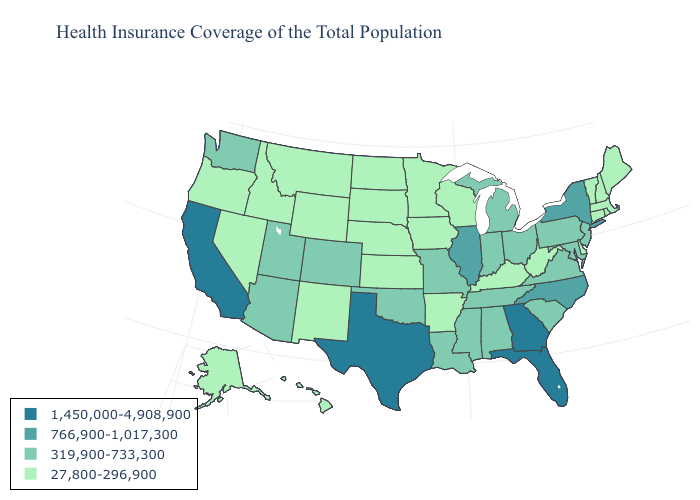How many symbols are there in the legend?
Answer briefly. 4. What is the value of Oregon?
Short answer required. 27,800-296,900. Does Kentucky have a higher value than Colorado?
Concise answer only. No. Name the states that have a value in the range 319,900-733,300?
Keep it brief. Alabama, Arizona, Colorado, Indiana, Louisiana, Maryland, Michigan, Mississippi, Missouri, New Jersey, Ohio, Oklahoma, Pennsylvania, South Carolina, Tennessee, Utah, Virginia, Washington. What is the value of Florida?
Concise answer only. 1,450,000-4,908,900. Name the states that have a value in the range 27,800-296,900?
Give a very brief answer. Alaska, Arkansas, Connecticut, Delaware, Hawaii, Idaho, Iowa, Kansas, Kentucky, Maine, Massachusetts, Minnesota, Montana, Nebraska, Nevada, New Hampshire, New Mexico, North Dakota, Oregon, Rhode Island, South Dakota, Vermont, West Virginia, Wisconsin, Wyoming. Does Iowa have the lowest value in the MidWest?
Quick response, please. Yes. What is the value of Minnesota?
Short answer required. 27,800-296,900. Does North Carolina have the highest value in the USA?
Keep it brief. No. Among the states that border Virginia , does Tennessee have the highest value?
Give a very brief answer. No. Does California have the highest value in the West?
Give a very brief answer. Yes. What is the lowest value in the USA?
Quick response, please. 27,800-296,900. Which states have the lowest value in the South?
Write a very short answer. Arkansas, Delaware, Kentucky, West Virginia. Does the map have missing data?
Be succinct. No. Does Nebraska have the highest value in the MidWest?
Write a very short answer. No. 